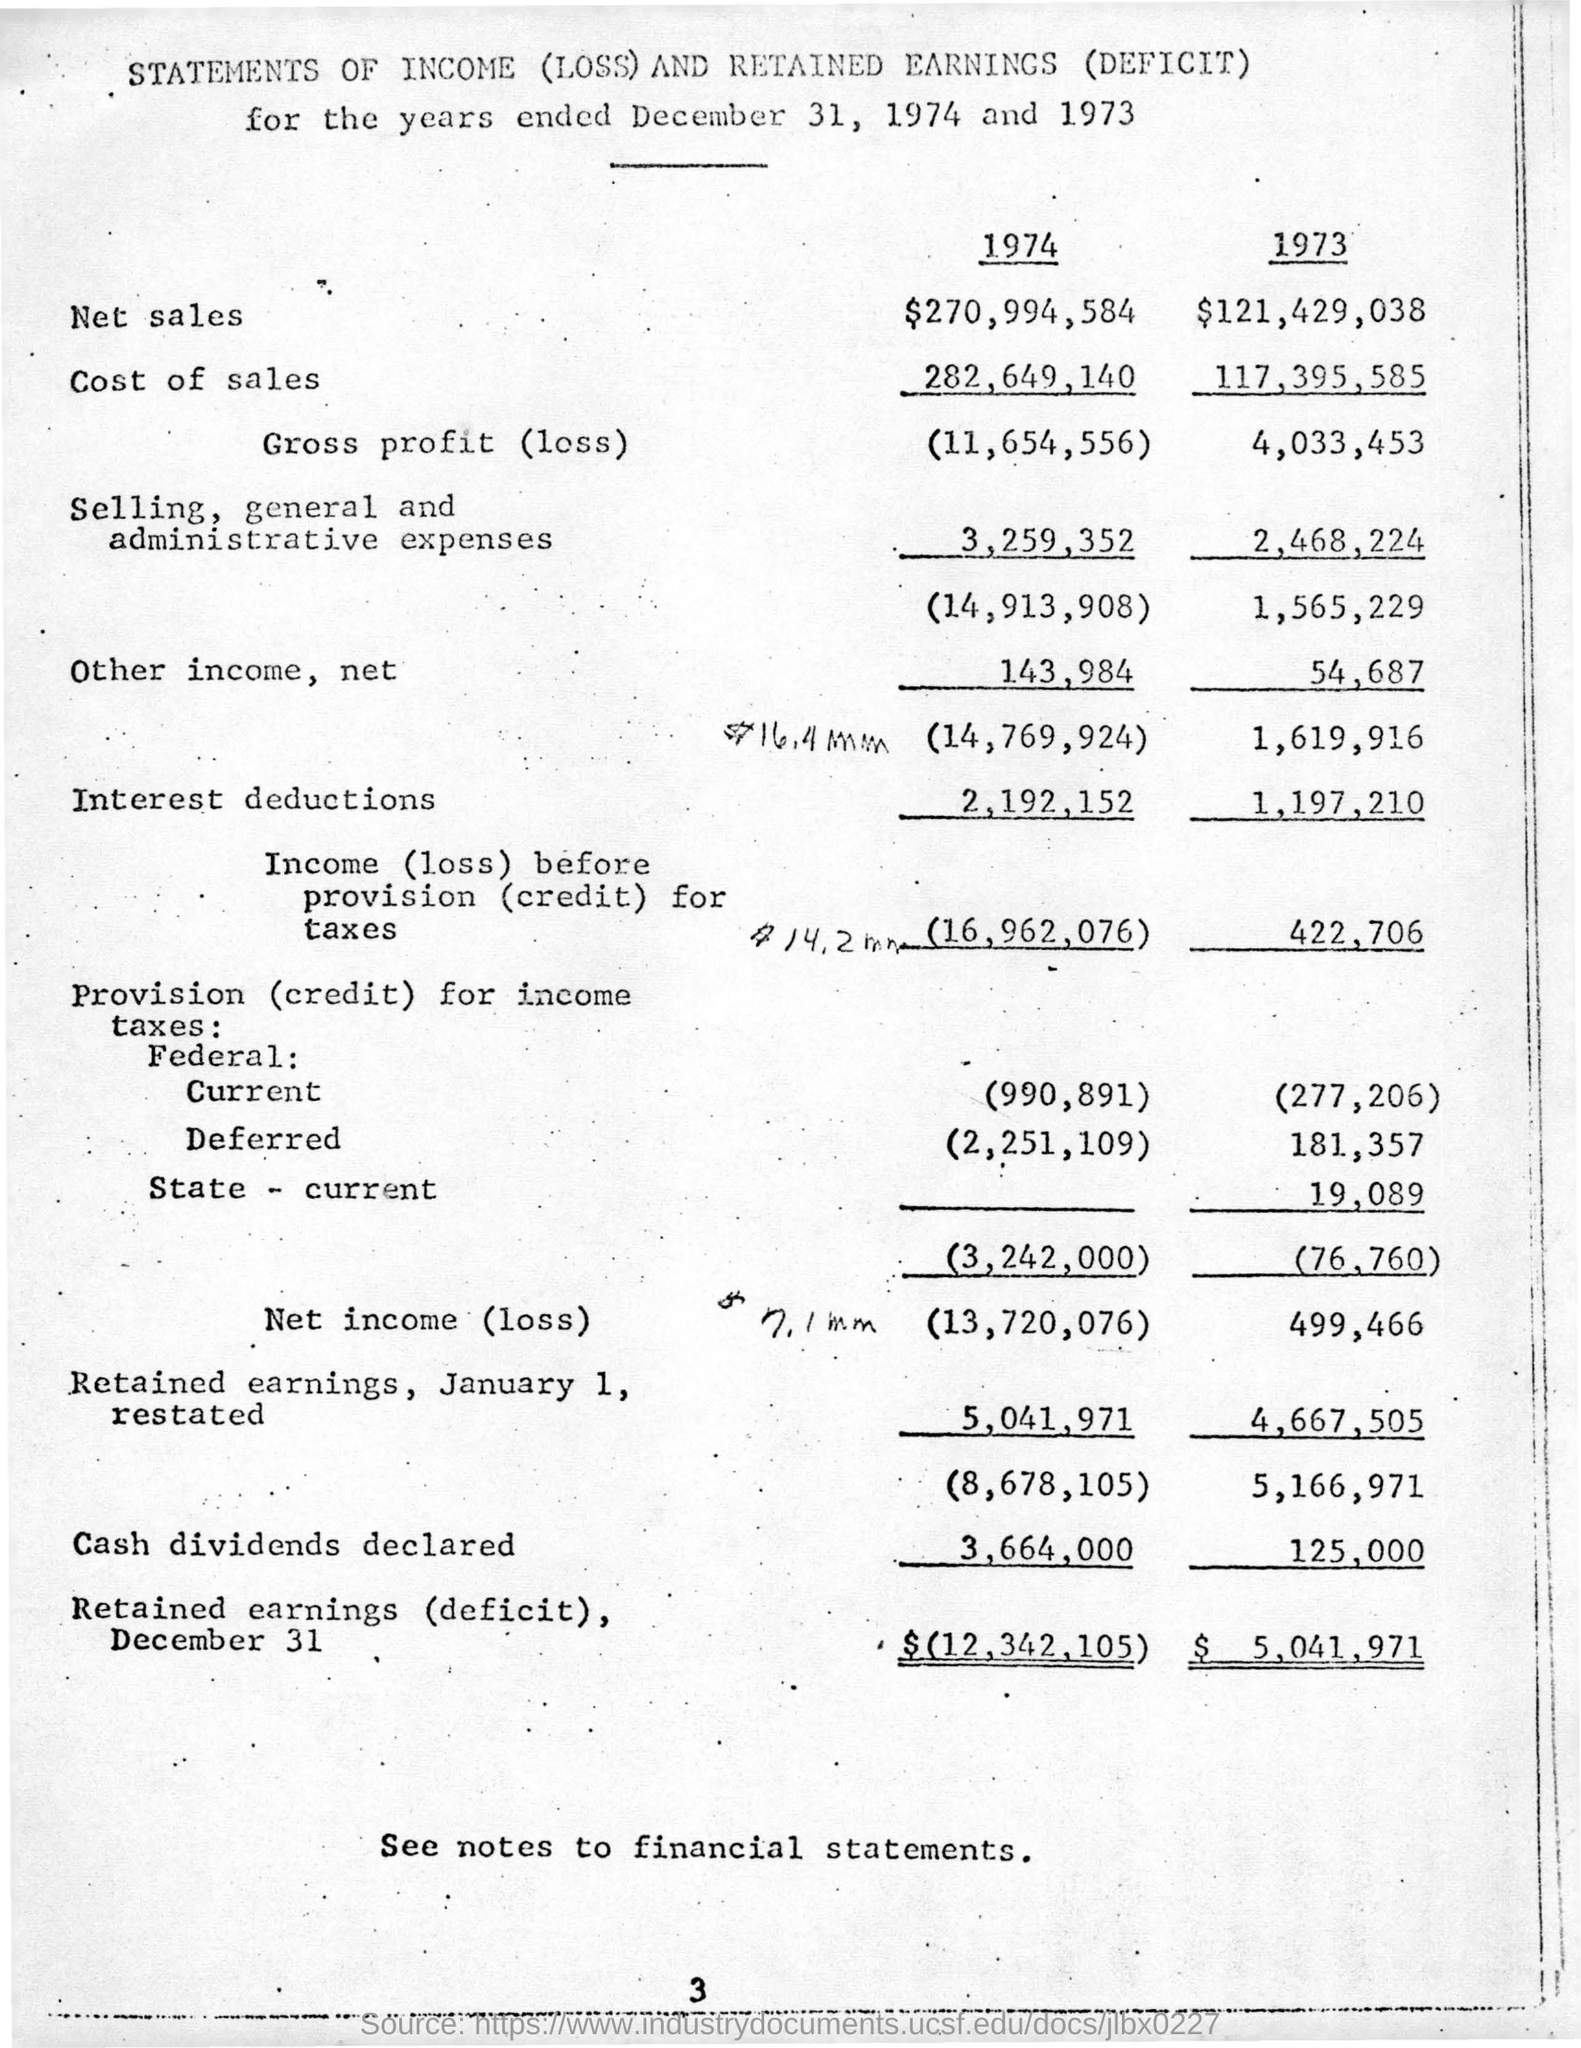Point out several critical features in this image. The net sales in 1974 were $270,994,584. The net income (loss) in the year 1973 was $499,466. The amount of selling, general, and administrative expenses in the year 1973 was $2,468,224. The cost of sales in the year 1973 was $117,395,585. The gross profit (loss) for the year 1974 was 11,654,556. 